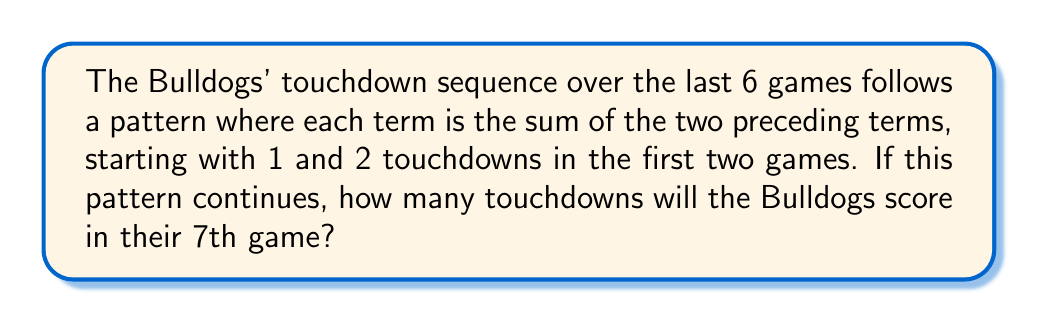Help me with this question. Let's break this down step-by-step:

1) First, let's write out the sequence for the first 6 games:
   Game 1: 1 touchdown
   Game 2: 2 touchdowns
   Game 3: $1 + 2 = 3$ touchdowns
   Game 4: $2 + 3 = 5$ touchdowns
   Game 5: $3 + 5 = 8$ touchdowns
   Game 6: $5 + 8 = 13$ touchdowns

2) We can see that this follows the Fibonacci sequence, where each term is the sum of the two preceding terms.

3) To find the number of touchdowns in the 7th game, we need to add the touchdowns from games 5 and 6:

   Game 7: $8 + 13 = 21$ touchdowns

4) Therefore, if this pattern continues, the Bulldogs will score 21 touchdowns in their 7th game.

This sequence can be represented mathematically as:

$$F_n = F_{n-1} + F_{n-2}$$

Where $F_n$ is the number of touchdowns in the nth game, and $F_1 = 1$, $F_2 = 2$.
Answer: 21 